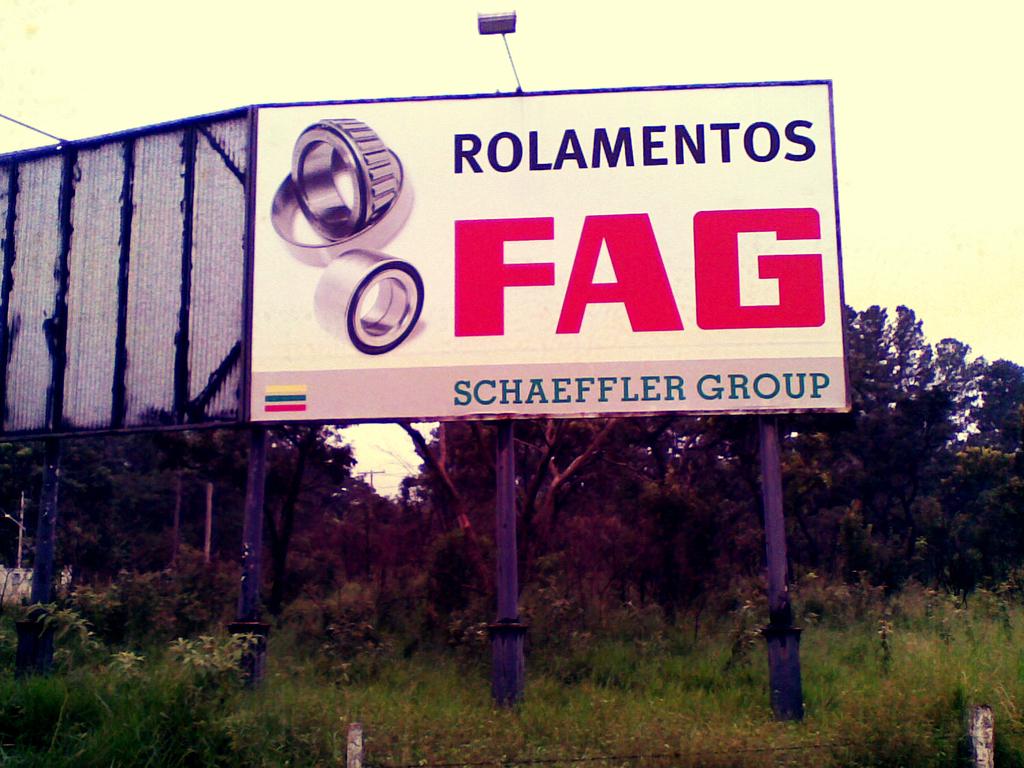What group has sponsored this sign?
Ensure brevity in your answer.  Schaeffler group. What is schaeffler group sponsoring?
Give a very brief answer. Rolamentos fag. 